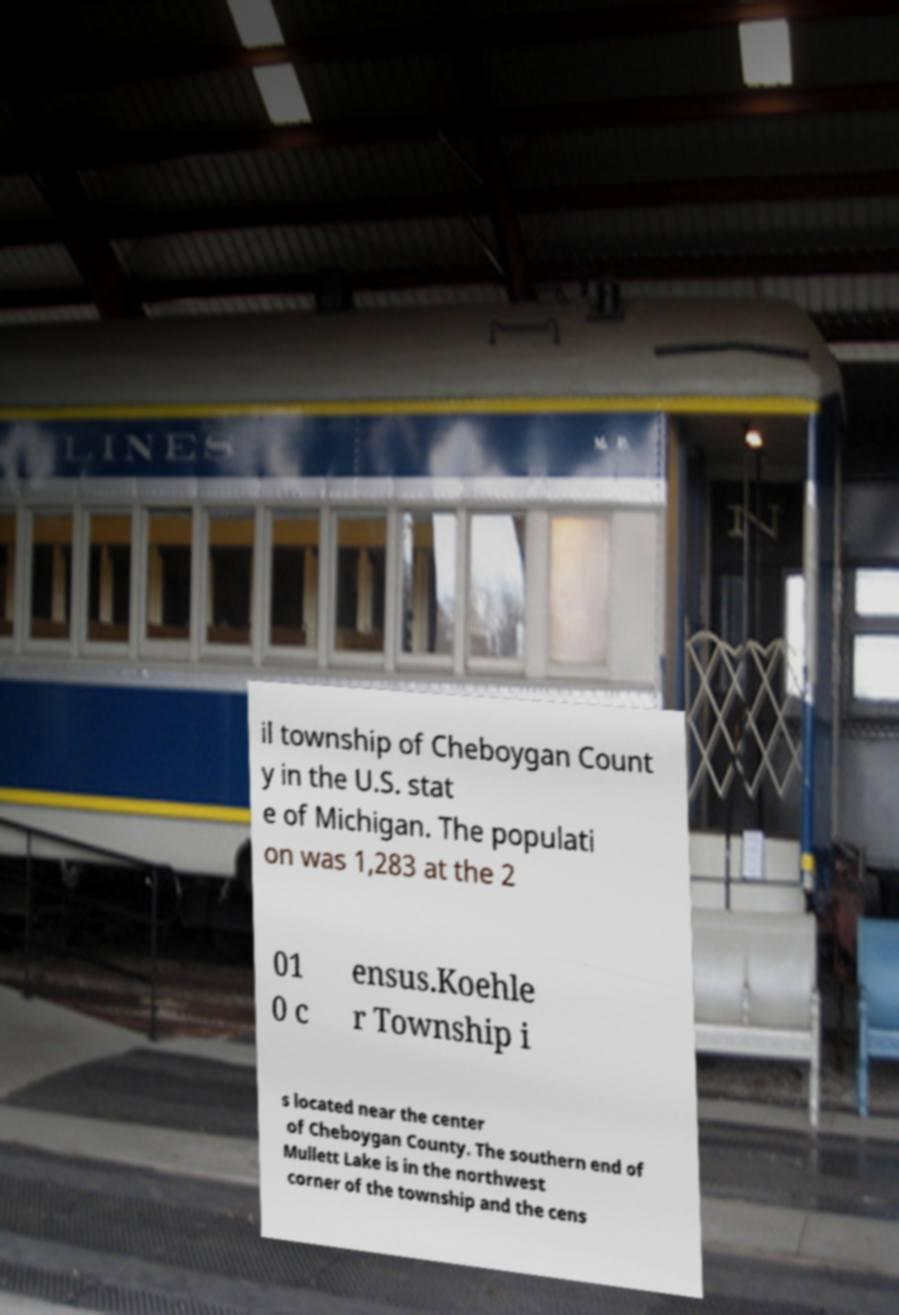Please read and relay the text visible in this image. What does it say? il township of Cheboygan Count y in the U.S. stat e of Michigan. The populati on was 1,283 at the 2 01 0 c ensus.Koehle r Township i s located near the center of Cheboygan County. The southern end of Mullett Lake is in the northwest corner of the township and the cens 